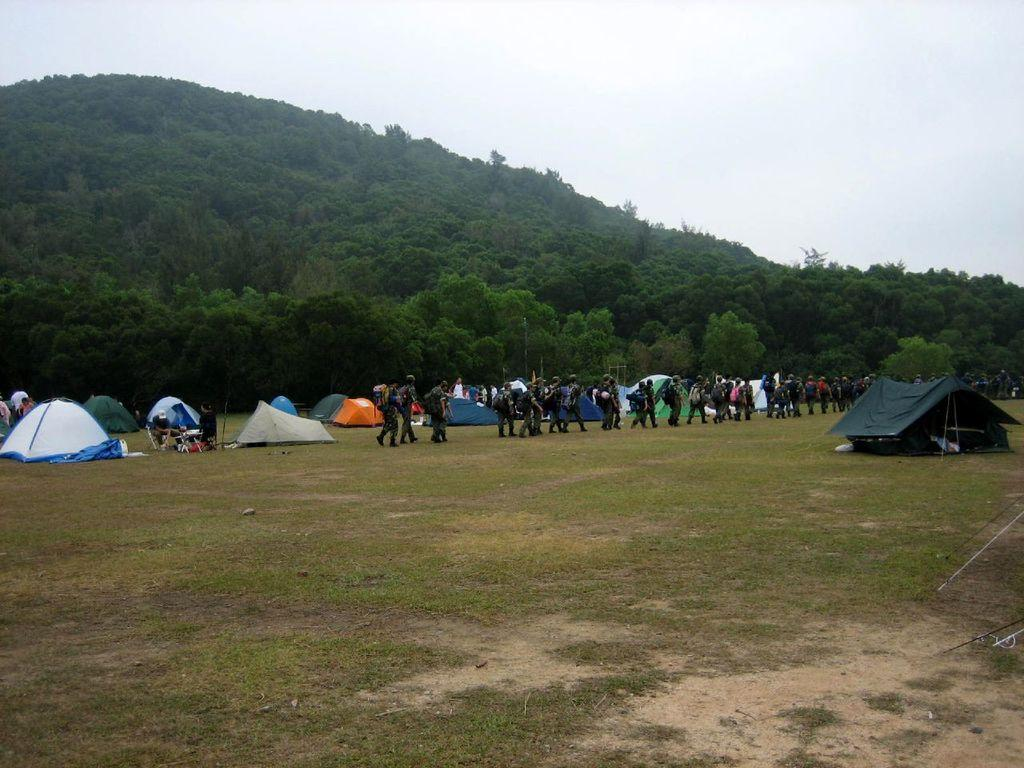What can be seen in the image? There is a group of people in the image. What are the people wearing? The people are wearing dresses. What are the people carrying? The people are carrying bags. What is on the ground in the image? There are tents on the ground in the image. What is visible in the background of the image? There are many trees, a mountain, and the sky visible in the background of the image. How many people are laughing in the image? There is no information about people laughing in the image. 